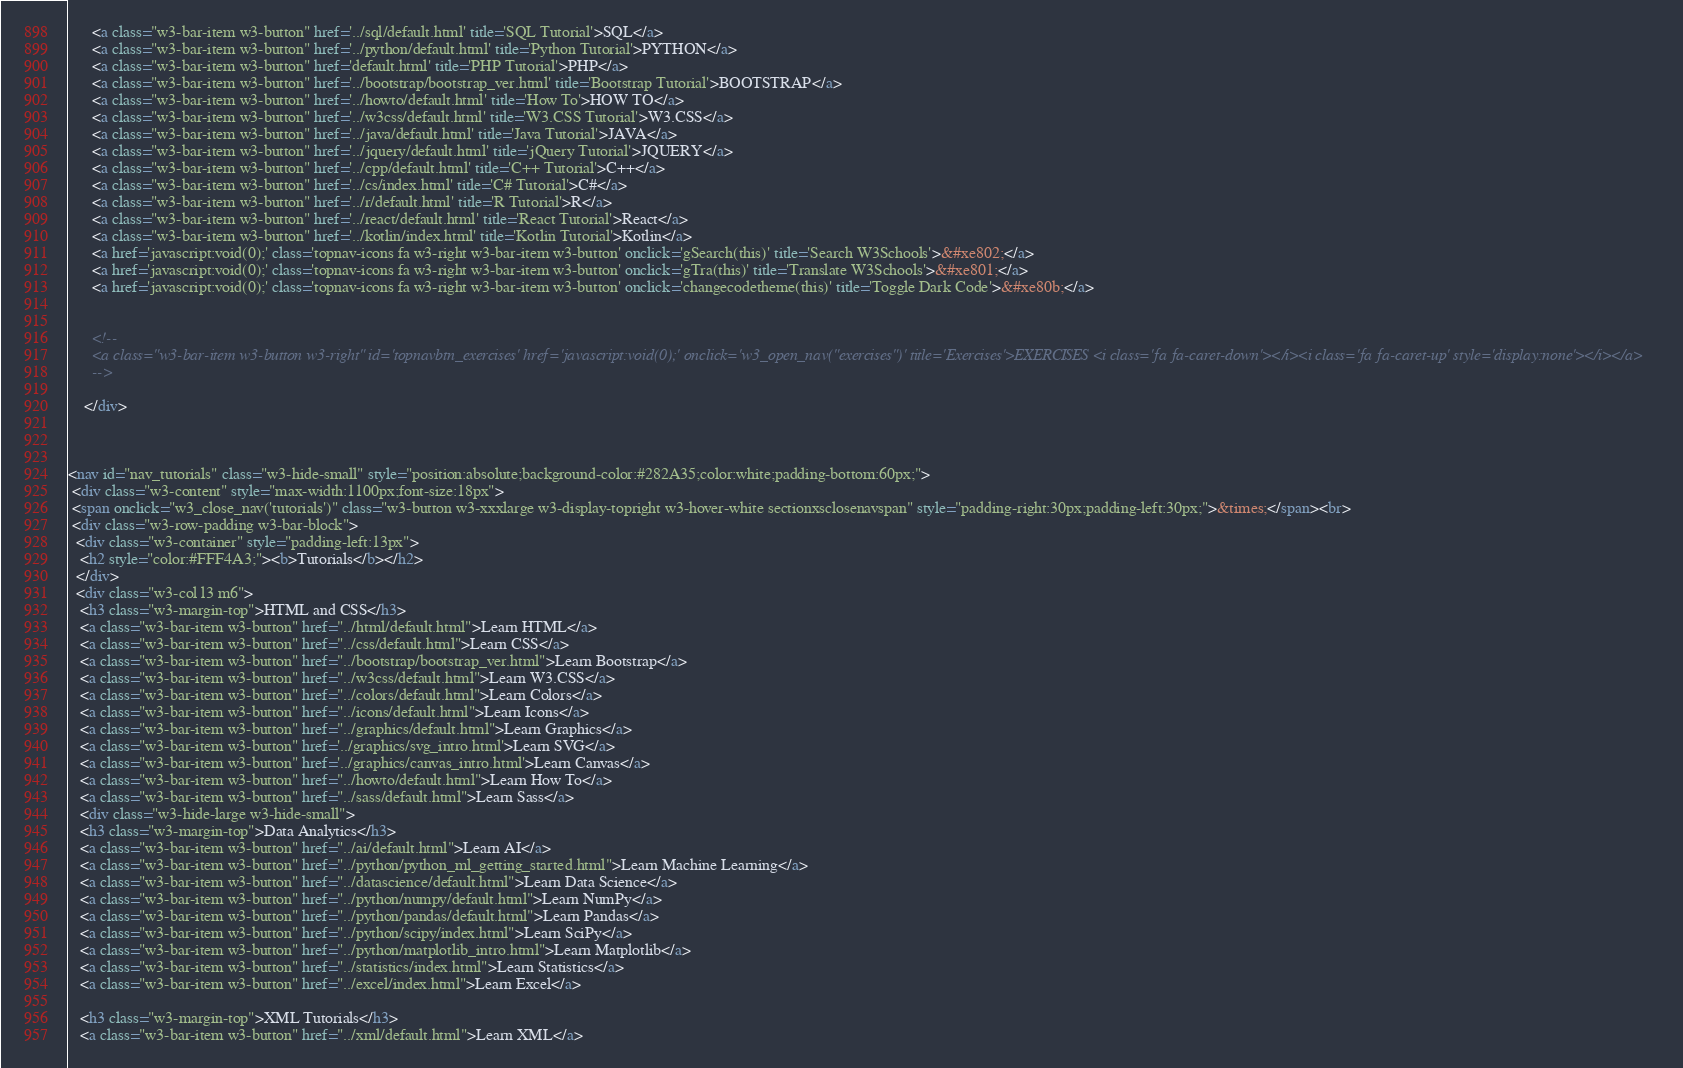Convert code to text. <code><loc_0><loc_0><loc_500><loc_500><_HTML_>      <a class="w3-bar-item w3-button" href='../sql/default.html' title='SQL Tutorial'>SQL</a>
      <a class="w3-bar-item w3-button" href='../python/default.html' title='Python Tutorial'>PYTHON</a>
      <a class="w3-bar-item w3-button" href='default.html' title='PHP Tutorial'>PHP</a>
      <a class="w3-bar-item w3-button" href='../bootstrap/bootstrap_ver.html' title='Bootstrap Tutorial'>BOOTSTRAP</a>
      <a class="w3-bar-item w3-button" href='../howto/default.html' title='How To'>HOW TO</a>
      <a class="w3-bar-item w3-button" href='../w3css/default.html' title='W3.CSS Tutorial'>W3.CSS</a>
      <a class="w3-bar-item w3-button" href='../java/default.html' title='Java Tutorial'>JAVA</a>
      <a class="w3-bar-item w3-button" href='../jquery/default.html' title='jQuery Tutorial'>JQUERY</a>
      <a class="w3-bar-item w3-button" href='../cpp/default.html' title='C++ Tutorial'>C++</a>
      <a class="w3-bar-item w3-button" href='../cs/index.html' title='C# Tutorial'>C#</a>
      <a class="w3-bar-item w3-button" href='../r/default.html' title='R Tutorial'>R</a>
      <a class="w3-bar-item w3-button" href='../react/default.html' title='React Tutorial'>React</a>
      <a class="w3-bar-item w3-button" href='../kotlin/index.html' title='Kotlin Tutorial'>Kotlin</a>
      <a href='javascript:void(0);' class='topnav-icons fa w3-right w3-bar-item w3-button' onclick='gSearch(this)' title='Search W3Schools'>&#xe802;</a>
      <a href='javascript:void(0);' class='topnav-icons fa w3-right w3-bar-item w3-button' onclick='gTra(this)' title='Translate W3Schools'>&#xe801;</a>
      <a href='javascript:void(0);' class='topnav-icons fa w3-right w3-bar-item w3-button' onclick='changecodetheme(this)' title='Toggle Dark Code'>&#xe80b;</a>


      <!--
      <a class="w3-bar-item w3-button w3-right" id='topnavbtn_exercises' href='javascript:void(0);' onclick='w3_open_nav("exercises")' title='Exercises'>EXERCISES <i class='fa fa-caret-down'></i><i class='fa fa-caret-up' style='display:none'></i></a>
      -->
      
    </div>
    


<nav id="nav_tutorials" class="w3-hide-small" style="position:absolute;background-color:#282A35;color:white;padding-bottom:60px;">
 <div class="w3-content" style="max-width:1100px;font-size:18px">
 <span onclick="w3_close_nav('tutorials')" class="w3-button w3-xxxlarge w3-display-topright w3-hover-white sectionxsclosenavspan" style="padding-right:30px;padding-left:30px;">&times;</span><br>
 <div class="w3-row-padding w3-bar-block">
  <div class="w3-container" style="padding-left:13px">
   <h2 style="color:#FFF4A3;"><b>Tutorials</b></h2>
  </div>
  <div class="w3-col l3 m6">
   <h3 class="w3-margin-top">HTML and CSS</h3>
   <a class="w3-bar-item w3-button" href="../html/default.html">Learn HTML</a>
   <a class="w3-bar-item w3-button" href="../css/default.html">Learn CSS</a>
   <a class="w3-bar-item w3-button" href="../bootstrap/bootstrap_ver.html">Learn Bootstrap</a>
   <a class="w3-bar-item w3-button" href="../w3css/default.html">Learn W3.CSS</a>
   <a class="w3-bar-item w3-button" href="../colors/default.html">Learn Colors</a>
   <a class="w3-bar-item w3-button" href="../icons/default.html">Learn Icons</a>
   <a class="w3-bar-item w3-button" href="../graphics/default.html">Learn Graphics</a>
   <a class="w3-bar-item w3-button" href='../graphics/svg_intro.html'>Learn SVG</a>
   <a class="w3-bar-item w3-button" href='../graphics/canvas_intro.html'>Learn Canvas</a>
   <a class="w3-bar-item w3-button" href="../howto/default.html">Learn How To</a>
   <a class="w3-bar-item w3-button" href="../sass/default.html">Learn Sass</a>   
   <div class="w3-hide-large w3-hide-small">
   <h3 class="w3-margin-top">Data Analytics</h3>
   <a class="w3-bar-item w3-button" href="../ai/default.html">Learn AI</a>
   <a class="w3-bar-item w3-button" href="../python/python_ml_getting_started.html">Learn Machine Learning</a>
   <a class="w3-bar-item w3-button" href="../datascience/default.html">Learn Data Science</a> 
   <a class="w3-bar-item w3-button" href="../python/numpy/default.html">Learn NumPy</a>       
   <a class="w3-bar-item w3-button" href="../python/pandas/default.html">Learn Pandas</a>    
   <a class="w3-bar-item w3-button" href="../python/scipy/index.html">Learn SciPy</a>    
   <a class="w3-bar-item w3-button" href="../python/matplotlib_intro.html">Learn Matplotlib</a>    
   <a class="w3-bar-item w3-button" href="../statistics/index.html">Learn Statistics</a>
   <a class="w3-bar-item w3-button" href="../excel/index.html">Learn Excel</a>

   <h3 class="w3-margin-top">XML Tutorials</h3>
   <a class="w3-bar-item w3-button" href="../xml/default.html">Learn XML</a></code> 